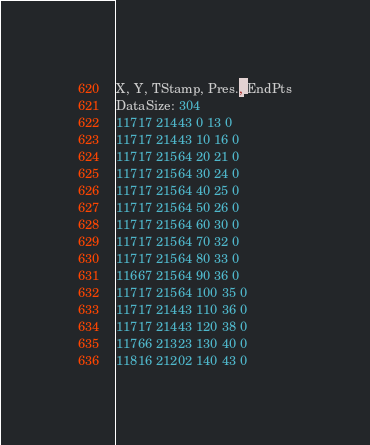<code> <loc_0><loc_0><loc_500><loc_500><_SML_>X, Y, TStamp, Pres., EndPts
DataSize: 304
11717 21443 0 13 0
11717 21443 10 16 0
11717 21564 20 21 0
11717 21564 30 24 0
11717 21564 40 25 0
11717 21564 50 26 0
11717 21564 60 30 0
11717 21564 70 32 0
11717 21564 80 33 0
11667 21564 90 36 0
11717 21564 100 35 0
11717 21443 110 36 0
11717 21443 120 38 0
11766 21323 130 40 0
11816 21202 140 43 0</code> 